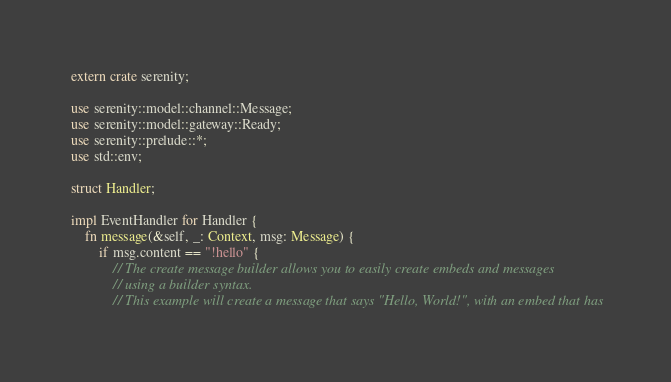Convert code to text. <code><loc_0><loc_0><loc_500><loc_500><_Rust_>extern crate serenity;

use serenity::model::channel::Message;
use serenity::model::gateway::Ready;
use serenity::prelude::*;
use std::env;

struct Handler;

impl EventHandler for Handler {
    fn message(&self, _: Context, msg: Message) {
        if msg.content == "!hello" {
            // The create message builder allows you to easily create embeds and messages
            // using a builder syntax.
            // This example will create a message that says "Hello, World!", with an embed that has</code> 